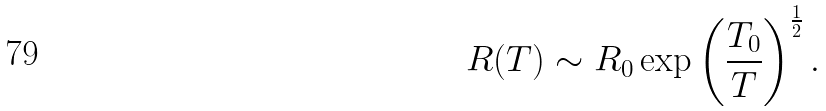Convert formula to latex. <formula><loc_0><loc_0><loc_500><loc_500>R ( T ) \sim R _ { 0 } \exp \left ( \frac { T _ { 0 } } { T } \right ) ^ { \frac { 1 } { 2 } } .</formula> 